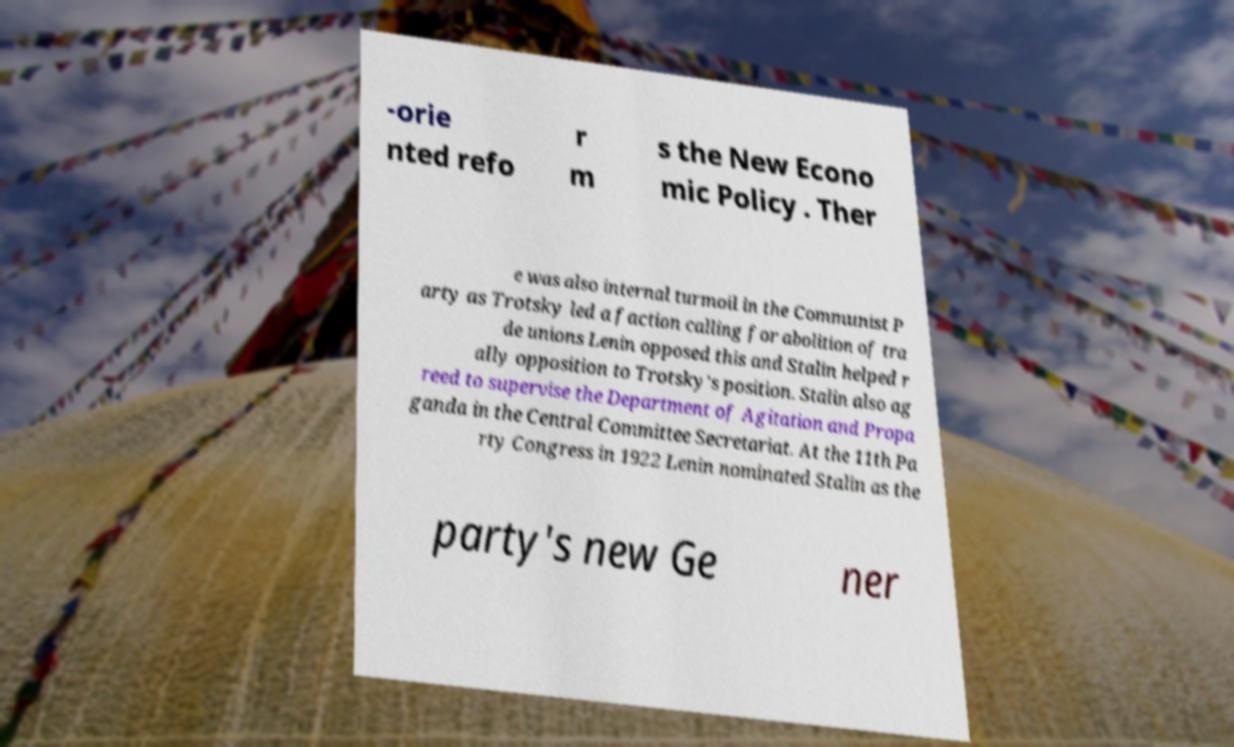Could you assist in decoding the text presented in this image and type it out clearly? -orie nted refo r m s the New Econo mic Policy . Ther e was also internal turmoil in the Communist P arty as Trotsky led a faction calling for abolition of tra de unions Lenin opposed this and Stalin helped r ally opposition to Trotsky's position. Stalin also ag reed to supervise the Department of Agitation and Propa ganda in the Central Committee Secretariat. At the 11th Pa rty Congress in 1922 Lenin nominated Stalin as the party's new Ge ner 